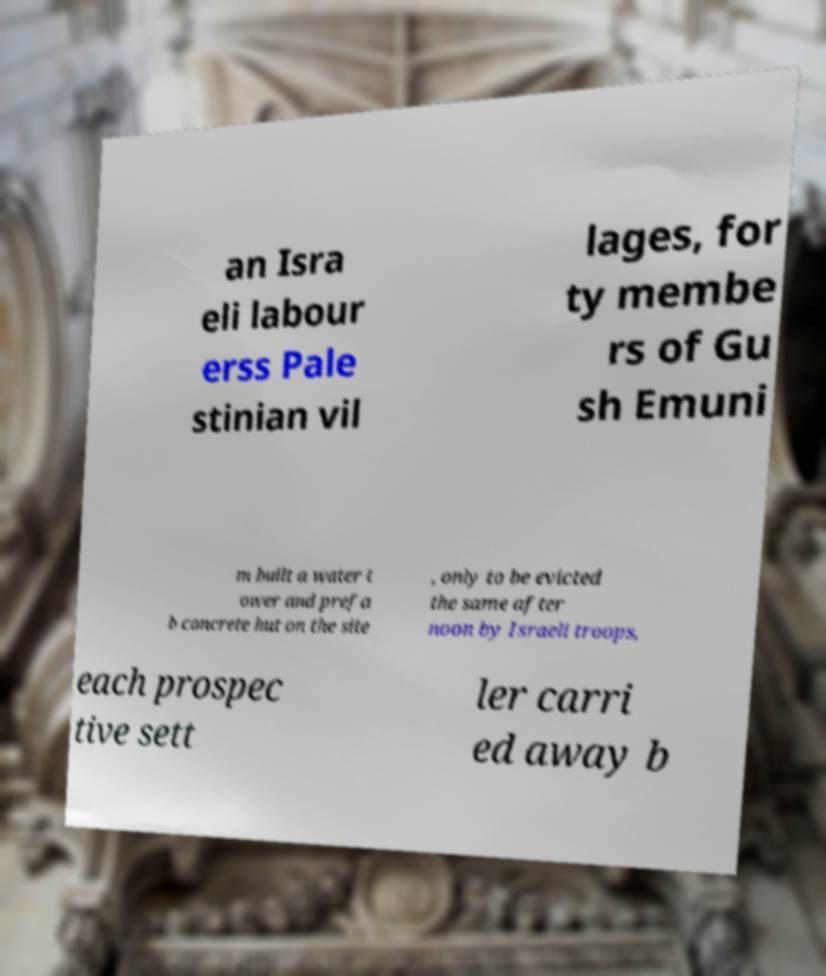There's text embedded in this image that I need extracted. Can you transcribe it verbatim? an Isra eli labour erss Pale stinian vil lages, for ty membe rs of Gu sh Emuni m built a water t ower and prefa b concrete hut on the site , only to be evicted the same after noon by Israeli troops, each prospec tive sett ler carri ed away b 